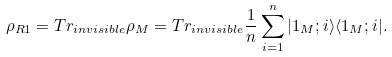<formula> <loc_0><loc_0><loc_500><loc_500>\rho _ { R 1 } = T r _ { i n v i s i b l e } \rho _ { M } = T r _ { i n v i s i b l e } \frac { 1 } { n } \sum _ { i = 1 } ^ { n } | 1 _ { M } ; i \rangle \langle 1 _ { M } ; i | .</formula> 